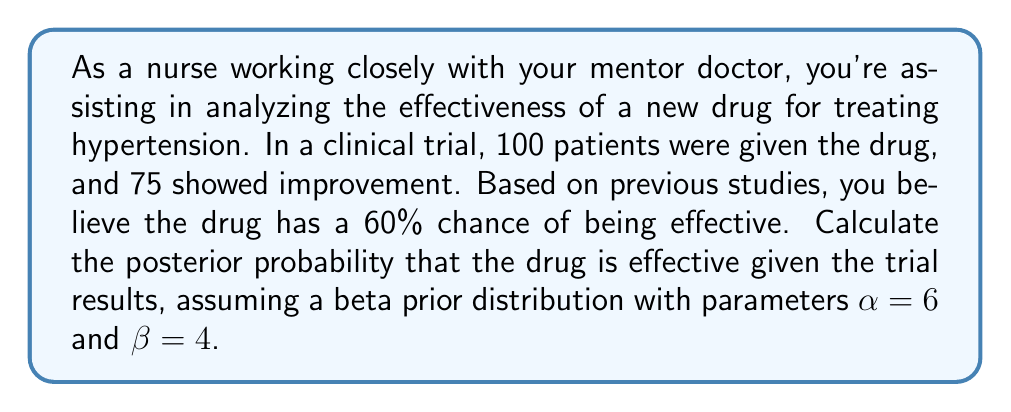Provide a solution to this math problem. To solve this problem, we'll use Bayesian inference with a beta-binomial model:

1. Prior distribution: Beta($\alpha=6$, $\beta=4$)
2. Likelihood: Binomial(n=100, k=75)
3. Posterior distribution: Beta($\alpha_{post}$, $\beta_{post}$)

Steps:

1. Calculate the parameters of the posterior distribution:
   $$\alpha_{post} = \alpha + k = 6 + 75 = 81$$
   $$\beta_{post} = \beta + (n - k) = 4 + (100 - 75) = 29$$

2. The posterior distribution is Beta(81, 29)

3. To find the posterior probability that the drug is effective, we need to calculate the expected value of this distribution:

   $$E[Beta(\alpha_{post}, \beta_{post})] = \frac{\alpha_{post}}{\alpha_{post} + \beta_{post}}$$

4. Substituting the values:

   $$E[Beta(81, 29)] = \frac{81}{81 + 29} = \frac{81}{110}$$

5. Calculate the final result:

   $$\frac{81}{110} \approx 0.7364$$

Thus, the posterior probability that the drug is effective, given the trial results, is approximately 0.7364 or 73.64%.
Answer: The posterior probability that the drug is effective, given the trial results, is approximately 0.7364 or 73.64%. 